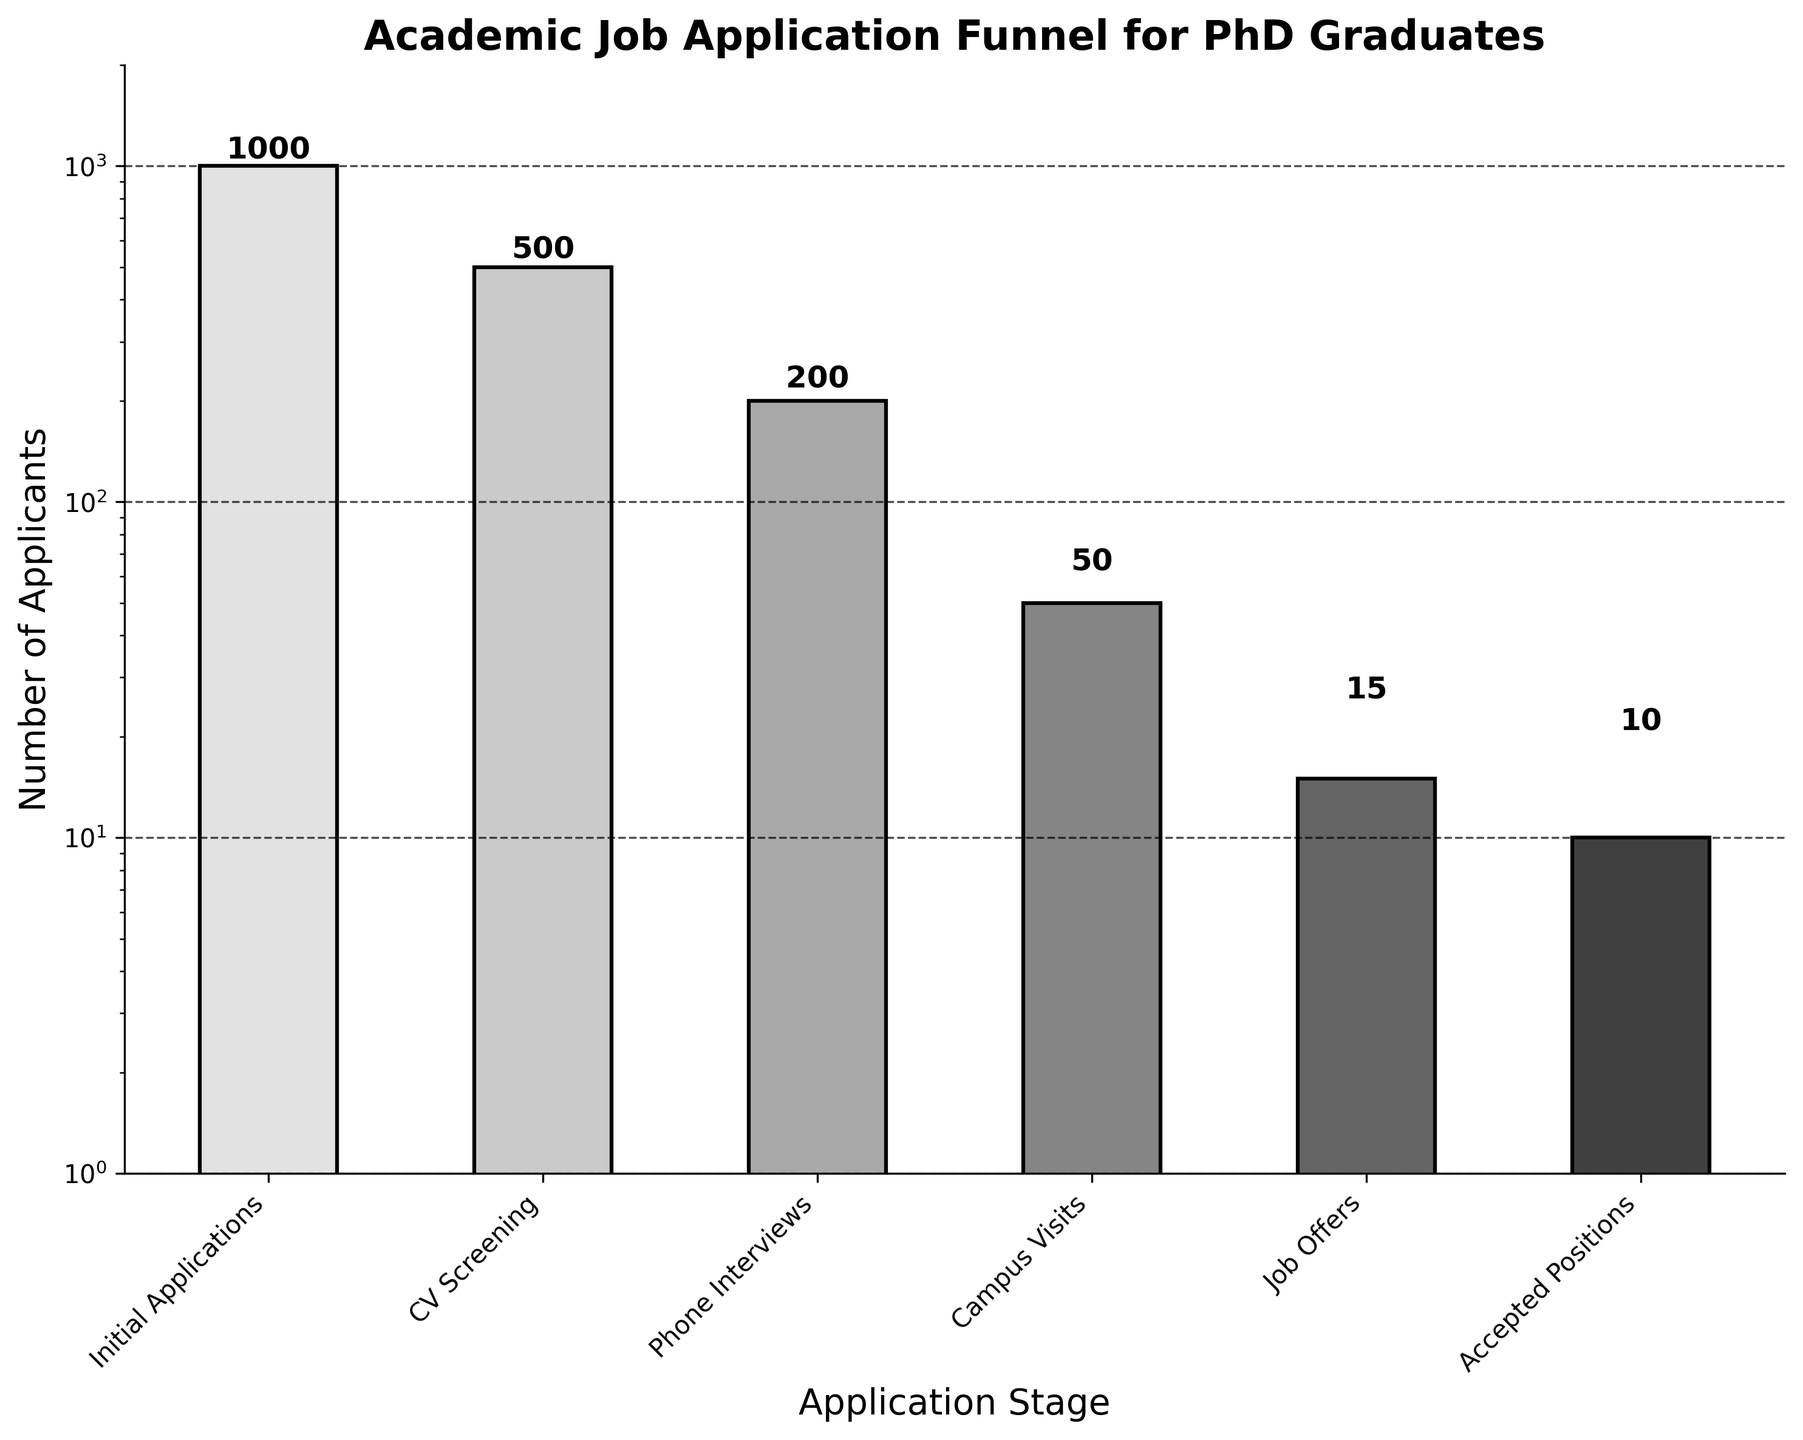What is the title of the chart? The title of the chart is displayed at the top and reads "Academic Job Application Funnel for PhD Graduates".
Answer: Academic Job Application Funnel for PhD Graduates What stage has the highest number of applicants? The stage with the highest number of applicants is the leftmost bar in the chart, which represents "Initial Applications" with 1000 applicants.
Answer: Initial Applications By how much do the number of applicants decrease from the CV Screening stage to the Phone Interviews stage? From the chart, the number of applicants in the CV Screening stage is 500 and in the Phone Interviews stage is 200. The decrease in applicants is calculated as 500 - 200.
Answer: 300 What is the ratio of applicants who progressed from Phone Interviews to Campus Visits? The chart shows 200 applicants in the Phone Interviews stage and 50 applicants in the Campus Visits stage. The ratio is 200/50, which simplifies to 4:1.
Answer: 4:1 Which stage has fewer applicants: Job Offers or Accepted Positions? By comparing the heights of the bars for "Job Offers" and "Accepted Positions", it is evident that "Accepted Positions" has fewer applicants (15 vs. 10).
Answer: Accepted Positions What percentage of the initial applicants receive job offers? The chart indicates that 15 applicants receive job offers out of the initial 1000 applicants. To find the percentage, calculate (15/1000) * 100.
Answer: 1.5% What is the logarithmic scale range used on the y-axis? The y-axis scale, displayed on the left of the chart, ranges from 1 to 2000 based on the logarithmic scale setting.
Answer: 1 to 2000 How many applicants advanced from the Initial Applications stage to the CV Screening stage? The number of applicants in the Initial Applications stage is 1000, and the number in the CV Screening stage is 500. The difference is 1000 - 500.
Answer: 500 Which stage has the steepest drop in the number of applicants? The steepest drop is between "Initial Applications" (1000 applicants) and "CV Screening" (500 applicants), resulting in a decrease of 500.
Answer: Between Initial Applications and CV Screening How many applicants are rejected before receiving a phone interview? The initial number of applicants is 1000, and those who progress to phone interviews are 200. Therefore, the number rejected before phone interviews is 1000 - 200.
Answer: 800 